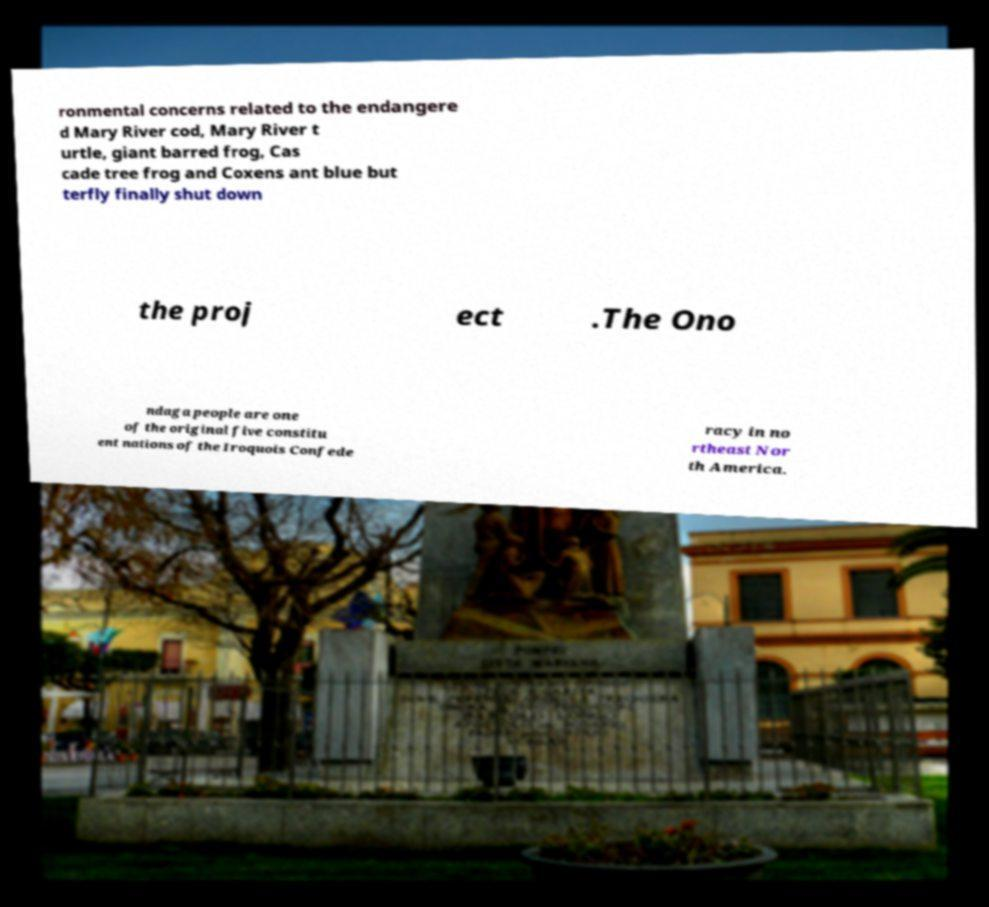Could you extract and type out the text from this image? ronmental concerns related to the endangere d Mary River cod, Mary River t urtle, giant barred frog, Cas cade tree frog and Coxens ant blue but terfly finally shut down the proj ect .The Ono ndaga people are one of the original five constitu ent nations of the Iroquois Confede racy in no rtheast Nor th America. 